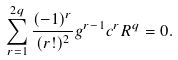Convert formula to latex. <formula><loc_0><loc_0><loc_500><loc_500>\sum _ { r = 1 } ^ { 2 q } \frac { ( - 1 ) ^ { r } } { ( r ! ) ^ { 2 } } g ^ { r - 1 } c ^ { r } R ^ { q } = 0 .</formula> 